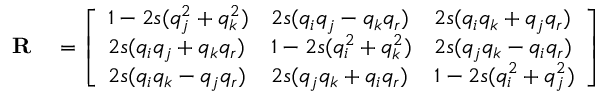<formula> <loc_0><loc_0><loc_500><loc_500>\begin{array} { r l } { R } & = { \left [ \begin{array} { l l l } { 1 - 2 s ( q _ { j } ^ { 2 } + q _ { k } ^ { 2 } ) } & { 2 s ( q _ { i } q _ { j } - q _ { k } q _ { r } ) } & { 2 s ( q _ { i } q _ { k } + q _ { j } q _ { r } ) } \\ { 2 s ( q _ { i } q _ { j } + q _ { k } q _ { r } ) } & { 1 - 2 s ( q _ { i } ^ { 2 } + q _ { k } ^ { 2 } ) } & { 2 s ( q _ { j } q _ { k } - q _ { i } q _ { r } ) } \\ { 2 s ( q _ { i } q _ { k } - q _ { j } q _ { r } ) } & { 2 s ( q _ { j } q _ { k } + q _ { i } q _ { r } ) } & { 1 - 2 s ( q _ { i } ^ { 2 } + q _ { j } ^ { 2 } ) } \end{array} \right ] } } \end{array}</formula> 